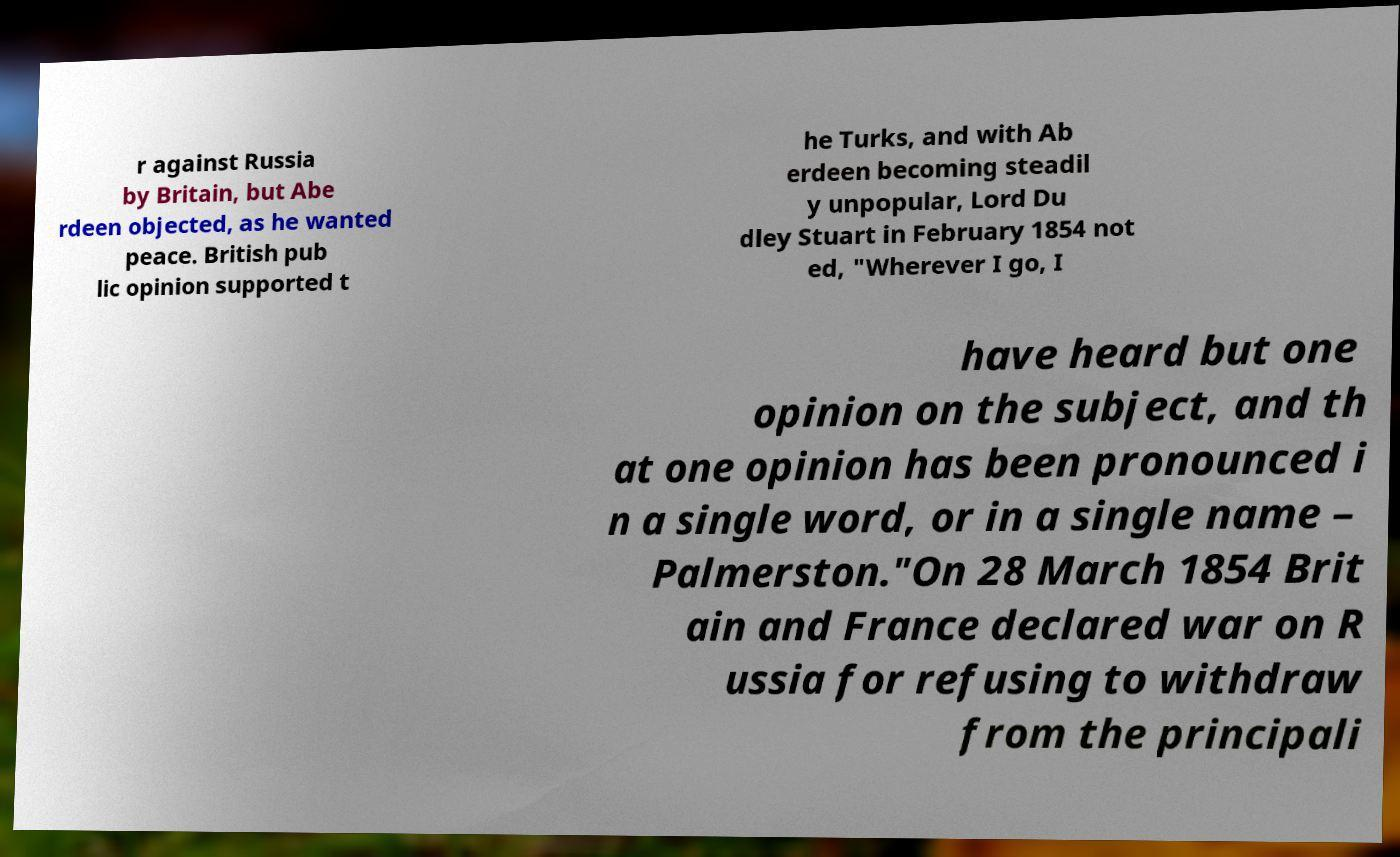Could you assist in decoding the text presented in this image and type it out clearly? r against Russia by Britain, but Abe rdeen objected, as he wanted peace. British pub lic opinion supported t he Turks, and with Ab erdeen becoming steadil y unpopular, Lord Du dley Stuart in February 1854 not ed, "Wherever I go, I have heard but one opinion on the subject, and th at one opinion has been pronounced i n a single word, or in a single name – Palmerston."On 28 March 1854 Brit ain and France declared war on R ussia for refusing to withdraw from the principali 